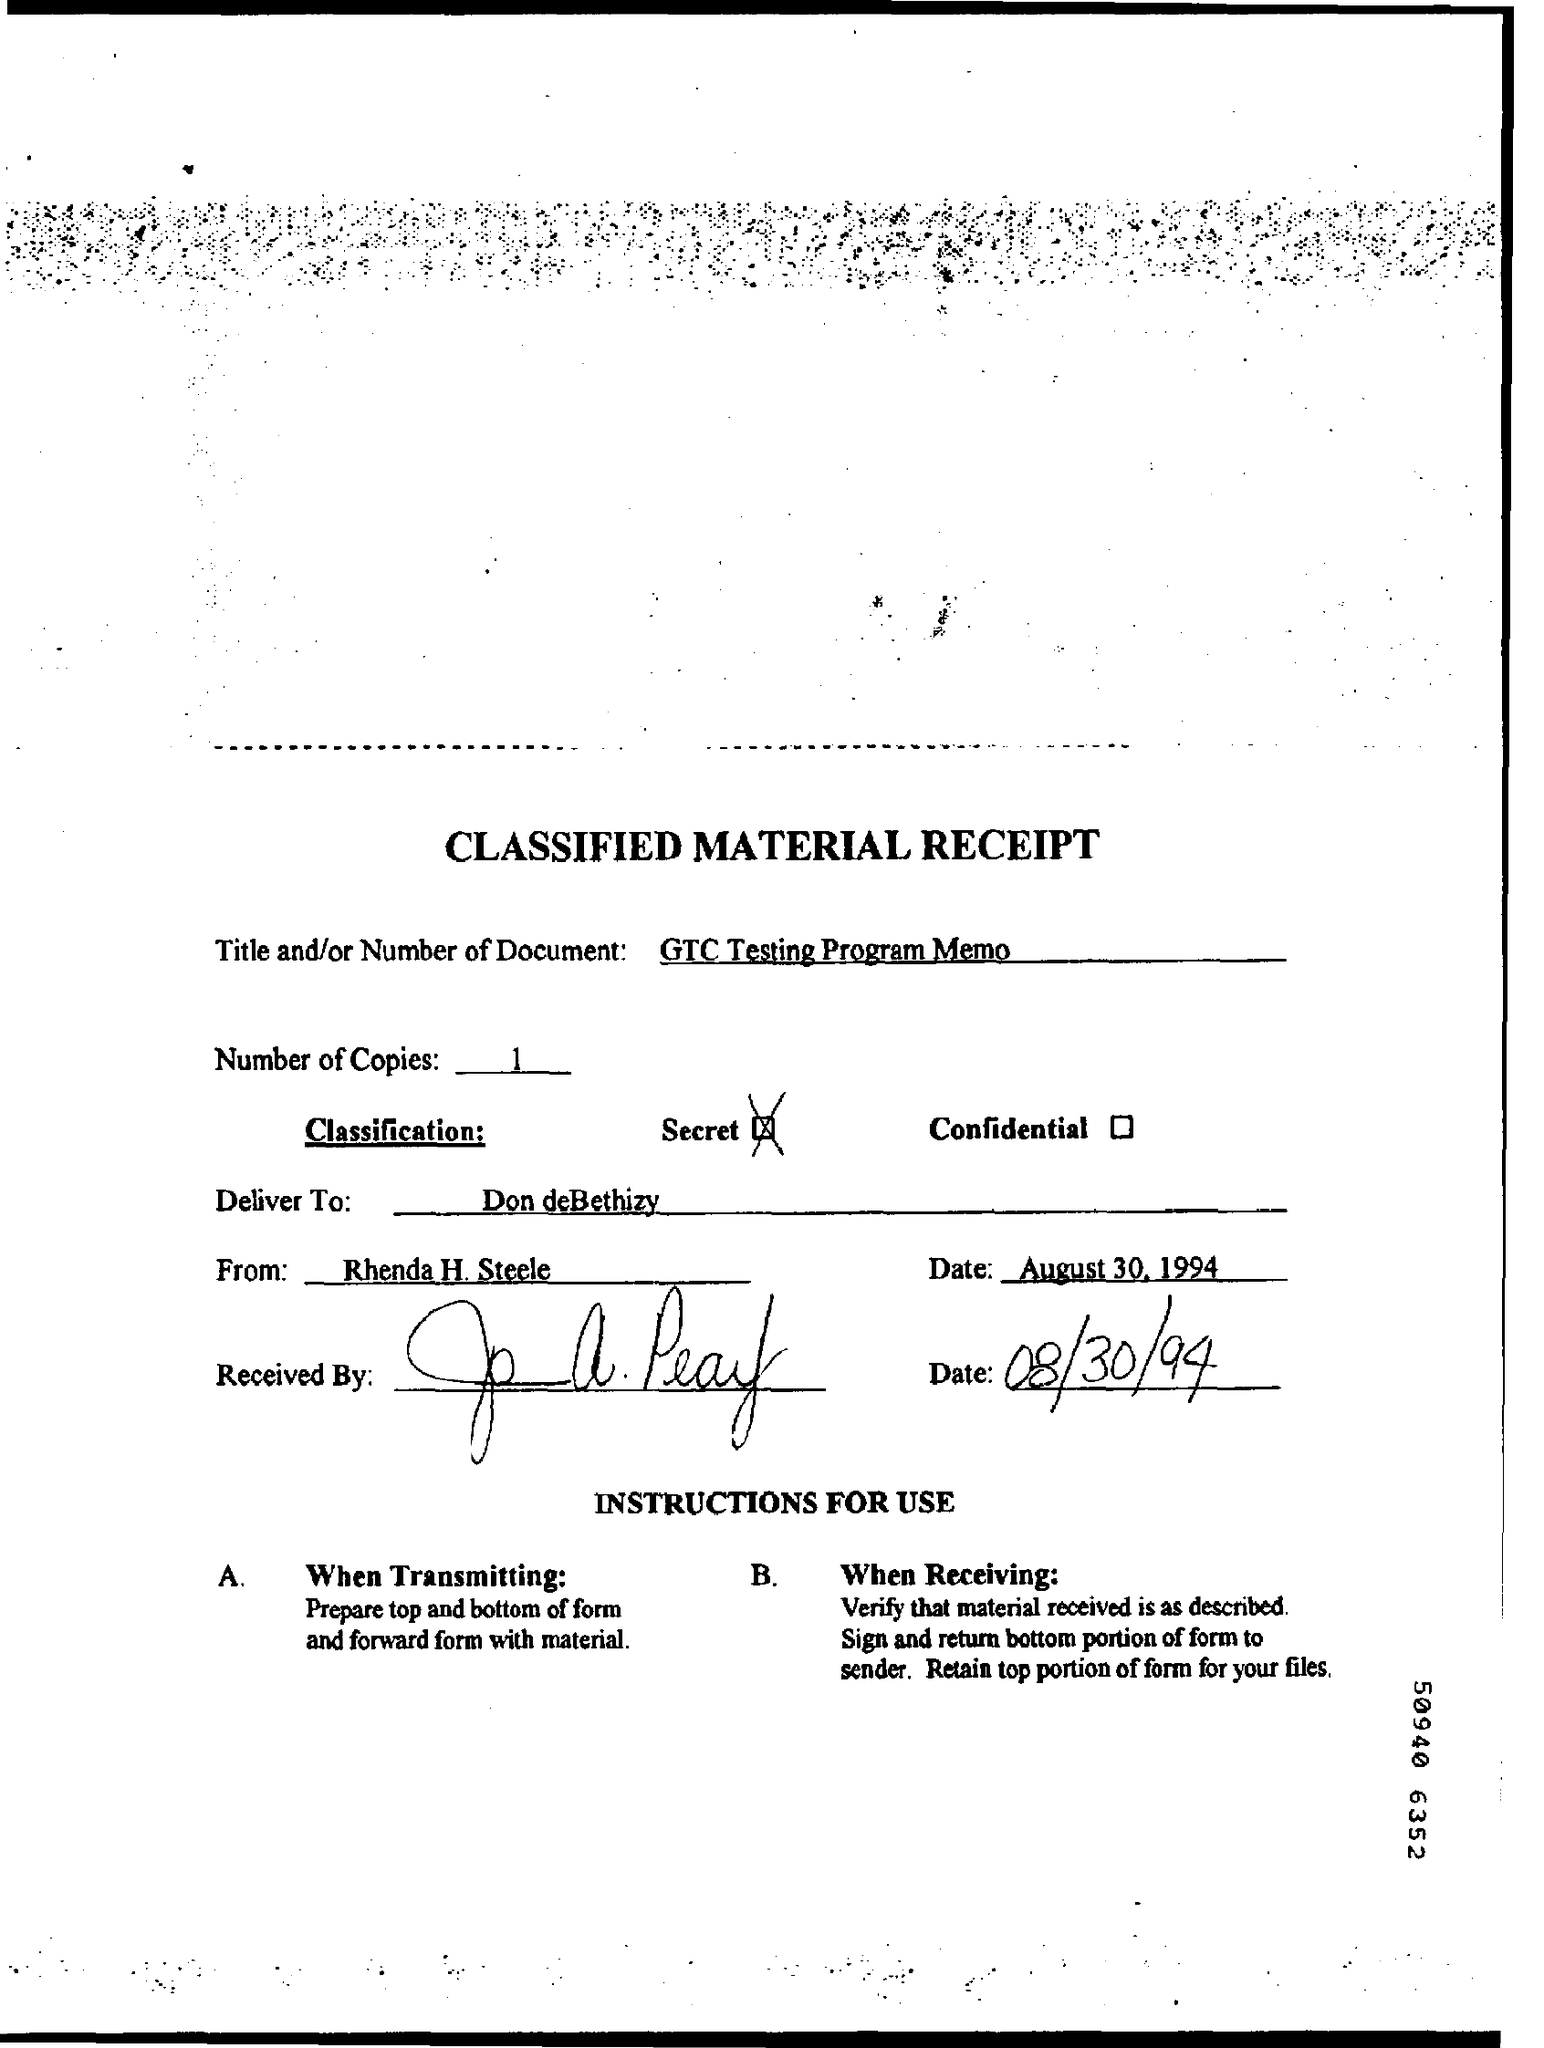Indicate a few pertinent items in this graphic. There are one or more copies of 1. The classification is a secret. 